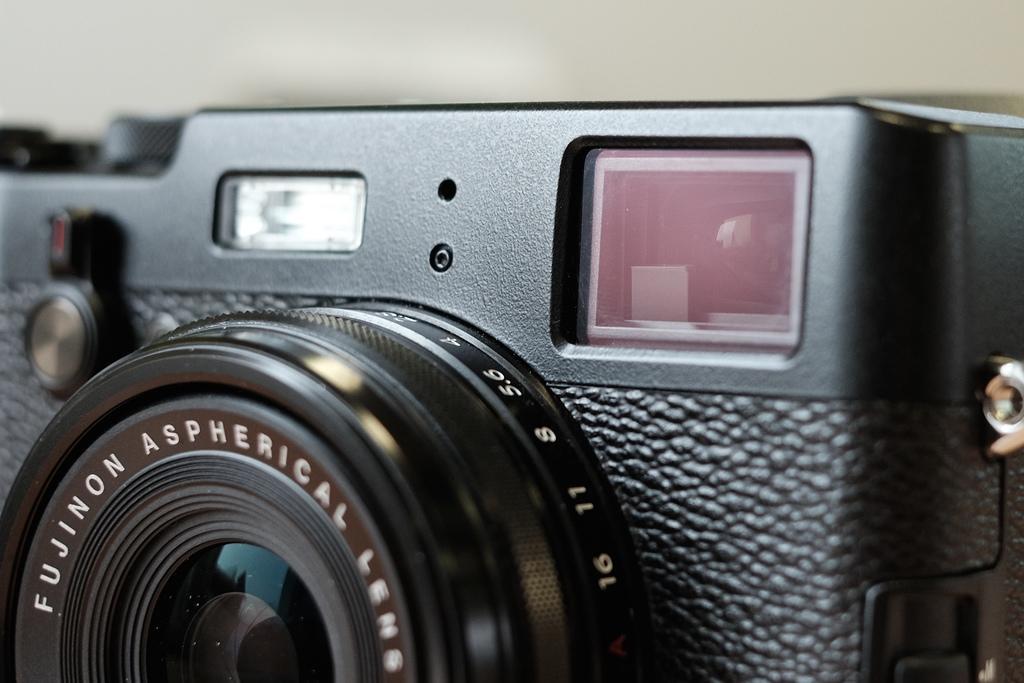How would you summarize this image in a sentence or two? In this image, we can see a camera. In the background, we can see white color. 